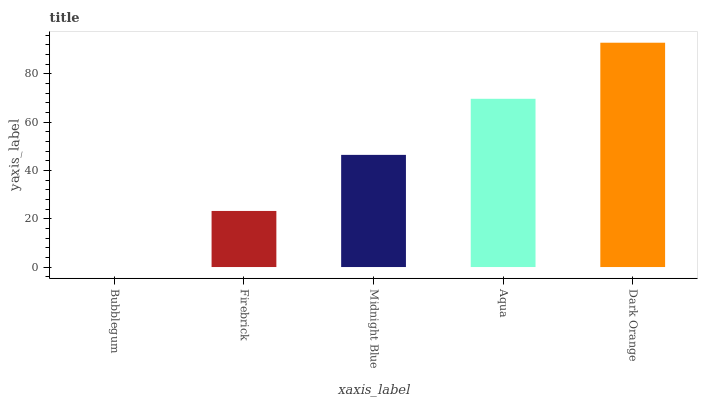Is Bubblegum the minimum?
Answer yes or no. Yes. Is Dark Orange the maximum?
Answer yes or no. Yes. Is Firebrick the minimum?
Answer yes or no. No. Is Firebrick the maximum?
Answer yes or no. No. Is Firebrick greater than Bubblegum?
Answer yes or no. Yes. Is Bubblegum less than Firebrick?
Answer yes or no. Yes. Is Bubblegum greater than Firebrick?
Answer yes or no. No. Is Firebrick less than Bubblegum?
Answer yes or no. No. Is Midnight Blue the high median?
Answer yes or no. Yes. Is Midnight Blue the low median?
Answer yes or no. Yes. Is Bubblegum the high median?
Answer yes or no. No. Is Firebrick the low median?
Answer yes or no. No. 